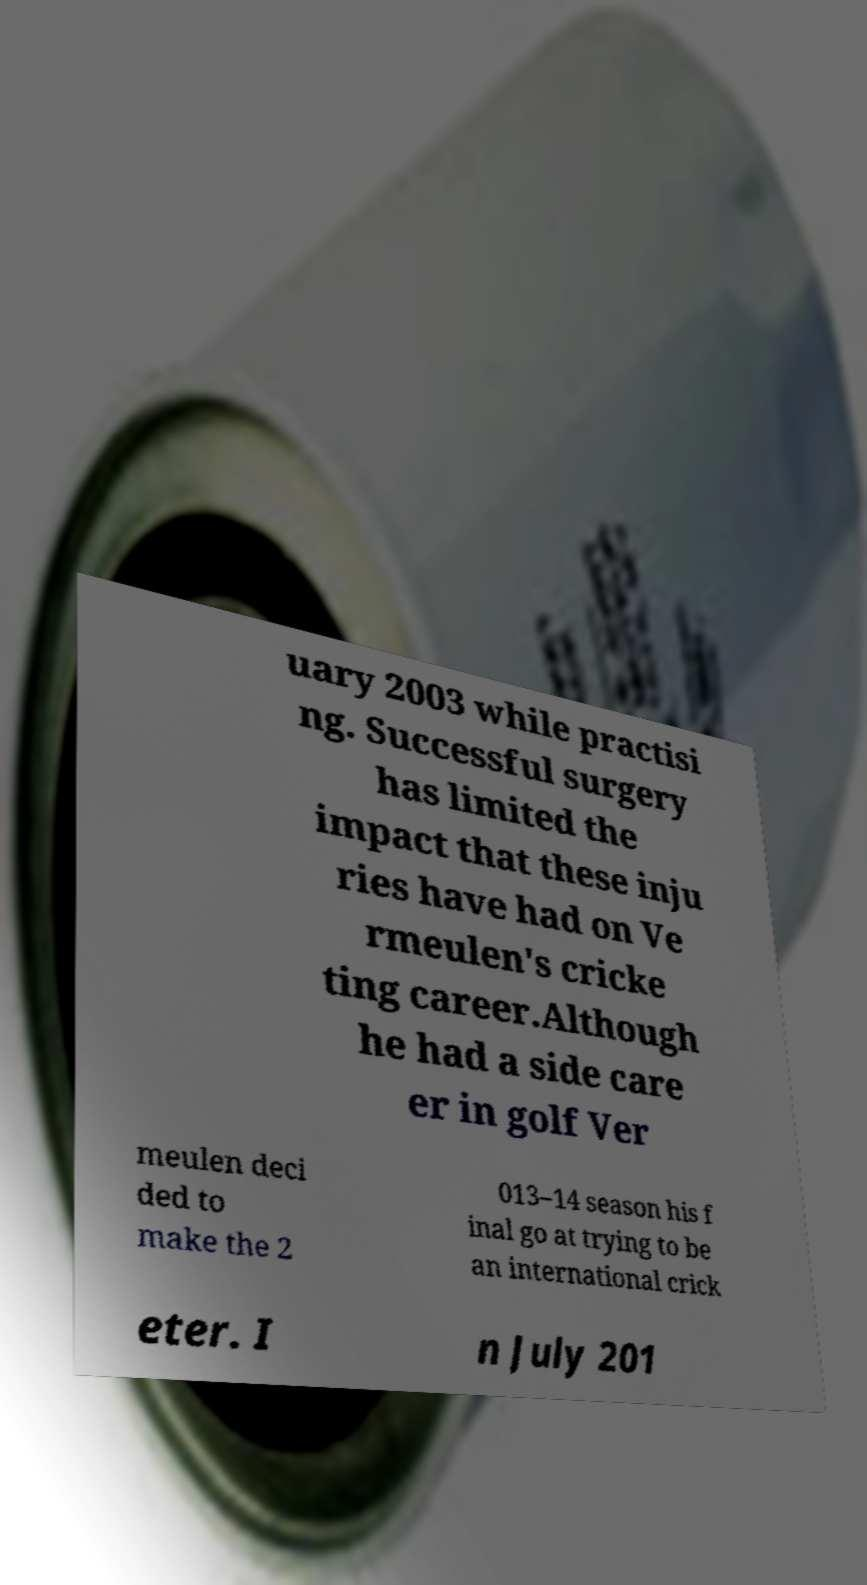For documentation purposes, I need the text within this image transcribed. Could you provide that? uary 2003 while practisi ng. Successful surgery has limited the impact that these inju ries have had on Ve rmeulen's cricke ting career.Although he had a side care er in golf Ver meulen deci ded to make the 2 013–14 season his f inal go at trying to be an international crick eter. I n July 201 